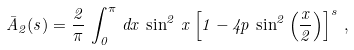Convert formula to latex. <formula><loc_0><loc_0><loc_500><loc_500>\bar { A } _ { 2 } ( s ) = \frac { 2 } { \pi } \, \int _ { 0 } ^ { \pi } \, d x \, \sin ^ { 2 } \, x \left [ 1 - 4 p \, \sin ^ { 2 } \left ( \frac { x } { 2 } \right ) \right ] ^ { s } \, ,</formula> 